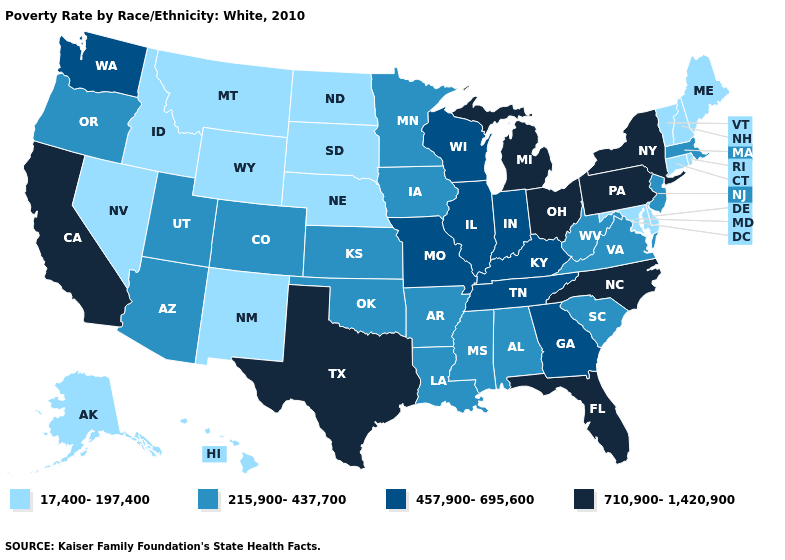What is the lowest value in states that border Missouri?
Answer briefly. 17,400-197,400. What is the value of Massachusetts?
Answer briefly. 215,900-437,700. What is the value of New York?
Answer briefly. 710,900-1,420,900. Among the states that border Maine , which have the highest value?
Quick response, please. New Hampshire. Does Hawaii have the same value as Colorado?
Be succinct. No. What is the value of North Dakota?
Keep it brief. 17,400-197,400. What is the highest value in the USA?
Keep it brief. 710,900-1,420,900. What is the lowest value in states that border Missouri?
Be succinct. 17,400-197,400. Name the states that have a value in the range 457,900-695,600?
Quick response, please. Georgia, Illinois, Indiana, Kentucky, Missouri, Tennessee, Washington, Wisconsin. What is the highest value in the USA?
Short answer required. 710,900-1,420,900. Does the map have missing data?
Give a very brief answer. No. What is the highest value in states that border Tennessee?
Write a very short answer. 710,900-1,420,900. Which states have the highest value in the USA?
Concise answer only. California, Florida, Michigan, New York, North Carolina, Ohio, Pennsylvania, Texas. Name the states that have a value in the range 710,900-1,420,900?
Be succinct. California, Florida, Michigan, New York, North Carolina, Ohio, Pennsylvania, Texas. 